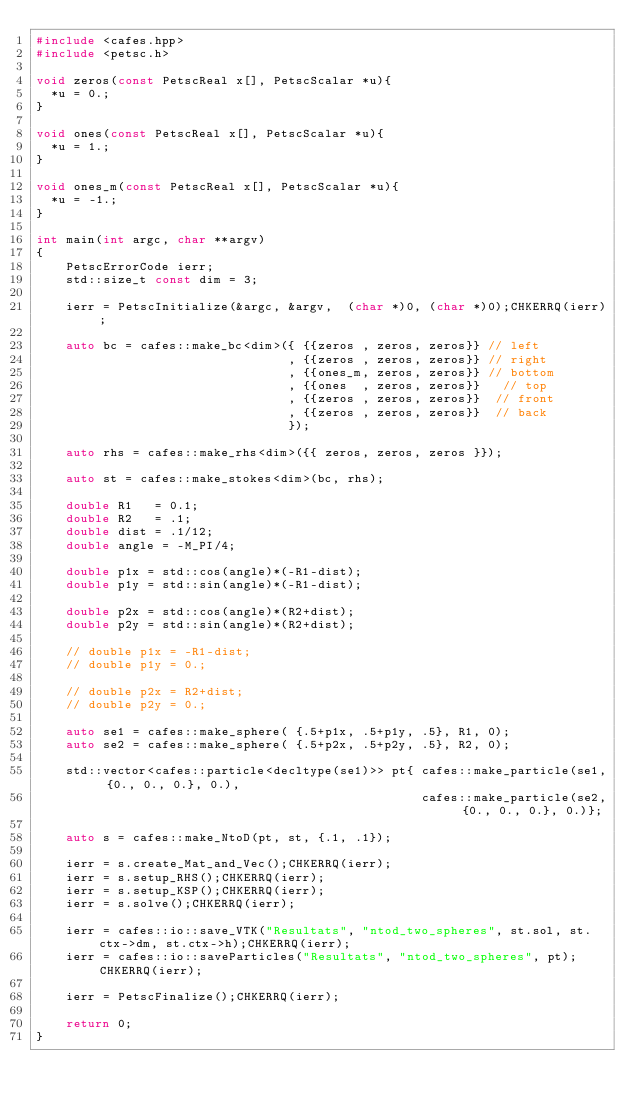<code> <loc_0><loc_0><loc_500><loc_500><_C++_>#include <cafes.hpp>
#include <petsc.h>

void zeros(const PetscReal x[], PetscScalar *u){
  *u = 0.;
}

void ones(const PetscReal x[], PetscScalar *u){
  *u = 1.;
}

void ones_m(const PetscReal x[], PetscScalar *u){
  *u = -1.;
}

int main(int argc, char **argv)
{
    PetscErrorCode ierr;
    std::size_t const dim = 3;

    ierr = PetscInitialize(&argc, &argv,  (char *)0, (char *)0);CHKERRQ(ierr);

    auto bc = cafes::make_bc<dim>({ {{zeros , zeros, zeros}} // left
                                  , {{zeros , zeros, zeros}} // right
                                  , {{ones_m, zeros, zeros}} // bottom
                                  , {{ones  , zeros, zeros}}   // top
                                  , {{zeros , zeros, zeros}}  // front
                                  , {{zeros , zeros, zeros}}  // back
                                  });

    auto rhs = cafes::make_rhs<dim>({{ zeros, zeros, zeros }});
    
    auto st = cafes::make_stokes<dim>(bc, rhs);

    double R1   = 0.1;
    double R2   = .1;
    double dist = .1/12;
    double angle = -M_PI/4;

    double p1x = std::cos(angle)*(-R1-dist);
    double p1y = std::sin(angle)*(-R1-dist);

    double p2x = std::cos(angle)*(R2+dist);
    double p2y = std::sin(angle)*(R2+dist);

    // double p1x = -R1-dist;
    // double p1y = 0.;

    // double p2x = R2+dist;
    // double p2y = 0.;

    auto se1 = cafes::make_sphere( {.5+p1x, .5+p1y, .5}, R1, 0);
    auto se2 = cafes::make_sphere( {.5+p2x, .5+p2y, .5}, R2, 0);

    std::vector<cafes::particle<decltype(se1)>> pt{ cafes::make_particle(se1, {0., 0., 0.}, 0.),
                                                    cafes::make_particle(se2, {0., 0., 0.}, 0.)};

    auto s = cafes::make_NtoD(pt, st, {.1, .1});

    ierr = s.create_Mat_and_Vec();CHKERRQ(ierr);
    ierr = s.setup_RHS();CHKERRQ(ierr);
    ierr = s.setup_KSP();CHKERRQ(ierr);
    ierr = s.solve();CHKERRQ(ierr);

    ierr = cafes::io::save_VTK("Resultats", "ntod_two_spheres", st.sol, st.ctx->dm, st.ctx->h);CHKERRQ(ierr);
    ierr = cafes::io::saveParticles("Resultats", "ntod_two_spheres", pt);CHKERRQ(ierr);

    ierr = PetscFinalize();CHKERRQ(ierr);

    return 0;
}
</code> 